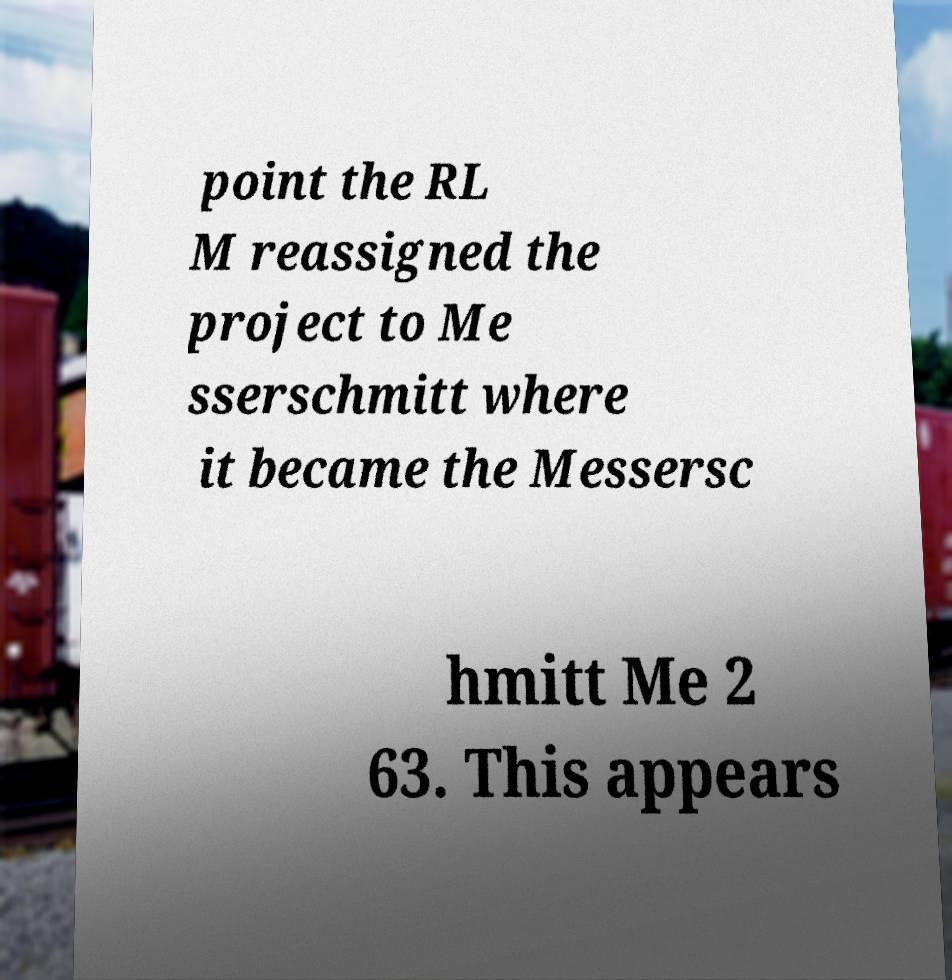There's text embedded in this image that I need extracted. Can you transcribe it verbatim? point the RL M reassigned the project to Me sserschmitt where it became the Messersc hmitt Me 2 63. This appears 